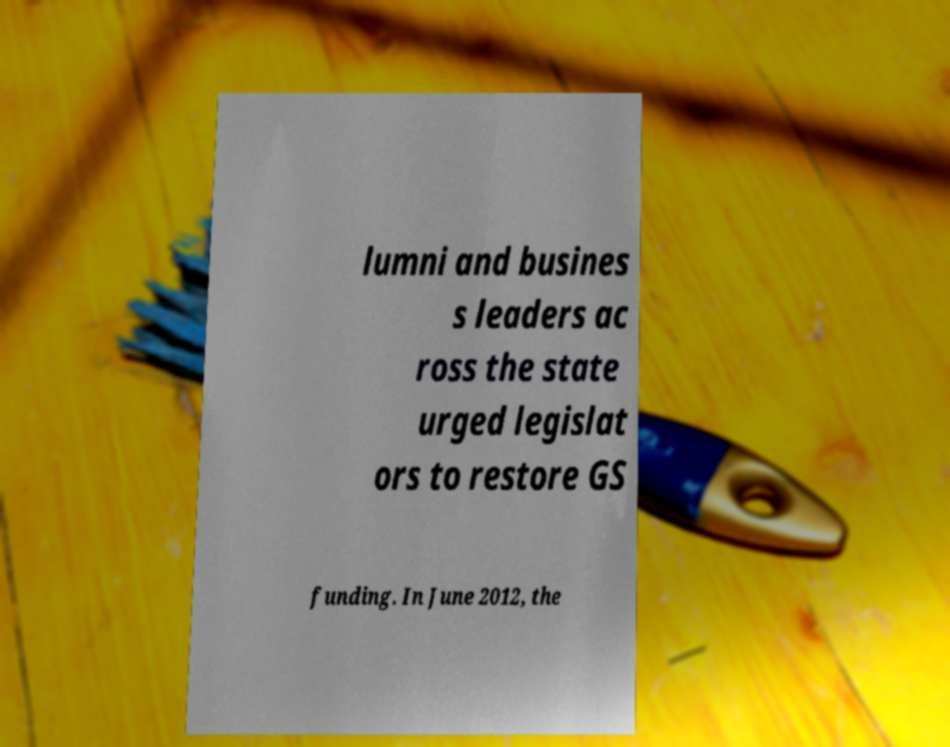There's text embedded in this image that I need extracted. Can you transcribe it verbatim? lumni and busines s leaders ac ross the state urged legislat ors to restore GS funding. In June 2012, the 